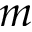Convert formula to latex. <formula><loc_0><loc_0><loc_500><loc_500>m</formula> 